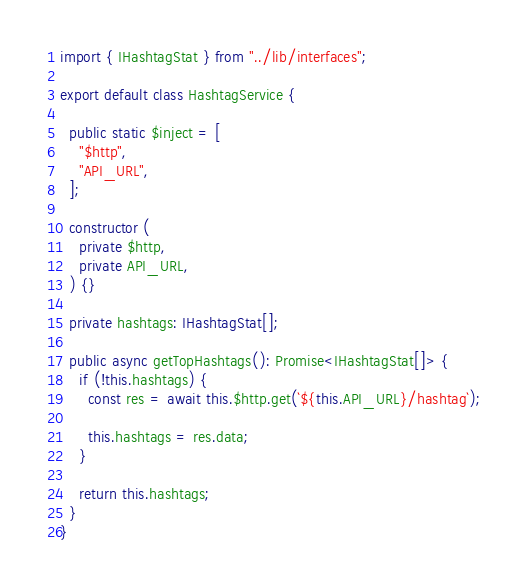<code> <loc_0><loc_0><loc_500><loc_500><_TypeScript_>import { IHashtagStat } from "../lib/interfaces";

export default class HashtagService {

  public static $inject = [
    "$http",
    "API_URL",
  ];

  constructor (
    private $http,
    private API_URL,
  ) {}

  private hashtags: IHashtagStat[];

  public async getTopHashtags(): Promise<IHashtagStat[]> {
    if (!this.hashtags) {
      const res = await this.$http.get(`${this.API_URL}/hashtag`);

      this.hashtags = res.data;
    }

    return this.hashtags;
  }
}
</code> 